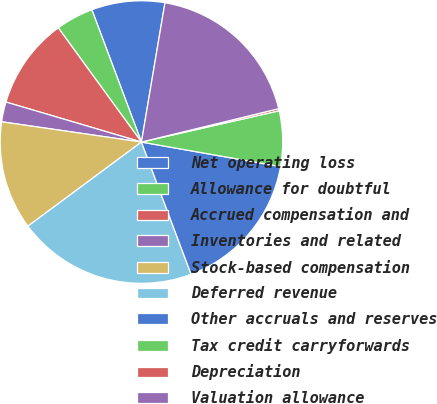Convert chart. <chart><loc_0><loc_0><loc_500><loc_500><pie_chart><fcel>Net operating loss<fcel>Allowance for doubtful<fcel>Accrued compensation and<fcel>Inventories and related<fcel>Stock-based compensation<fcel>Deferred revenue<fcel>Other accruals and reserves<fcel>Tax credit carryforwards<fcel>Depreciation<fcel>Valuation allowance<nl><fcel>8.37%<fcel>4.31%<fcel>10.41%<fcel>2.28%<fcel>12.44%<fcel>20.57%<fcel>16.5%<fcel>6.34%<fcel>0.24%<fcel>18.54%<nl></chart> 